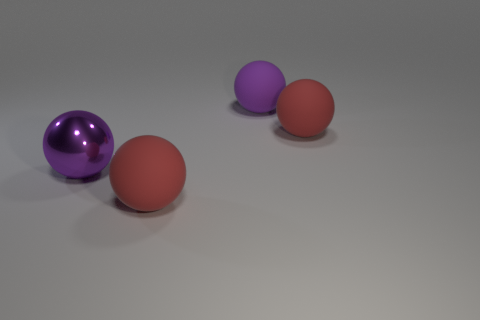Subtract all brown balls. Subtract all cyan cubes. How many balls are left? 4 Add 2 large rubber spheres. How many objects exist? 6 Add 4 large purple shiny balls. How many large purple shiny balls exist? 5 Subtract 0 green cubes. How many objects are left? 4 Subtract all spheres. Subtract all large blue metallic blocks. How many objects are left? 0 Add 3 large red balls. How many large red balls are left? 5 